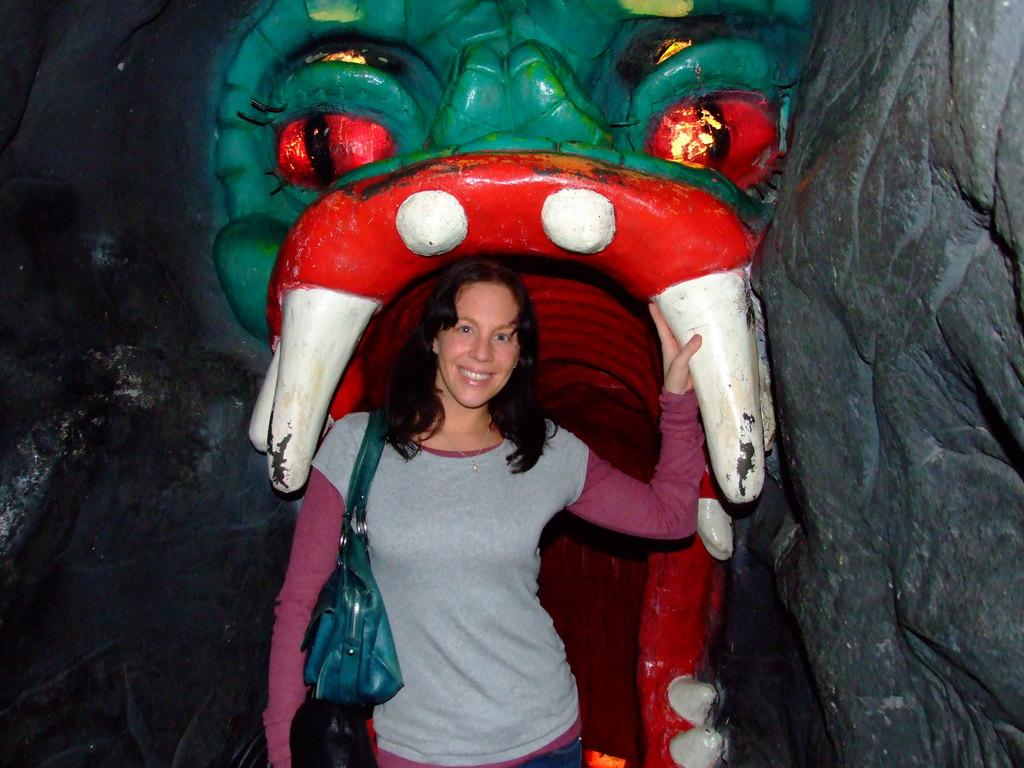What is the main subject of the image? There is a person standing in the image. What is the person wearing in the image? The person is wearing a handbag. What can be seen in the background of the image? There is a rock carving in the background. How is the rock carving decorated? The rock carving is painted with different colors. What type of sidewalk can be seen near the rock carving in the image? There is no sidewalk present in the image; it features a person standing and a rock carving in the background. Can you tell me how many wishes are granted by the rock carving in the image? The image does not depict any wishes being granted by the rock carving; it is simply a painted rock carving in the background. 